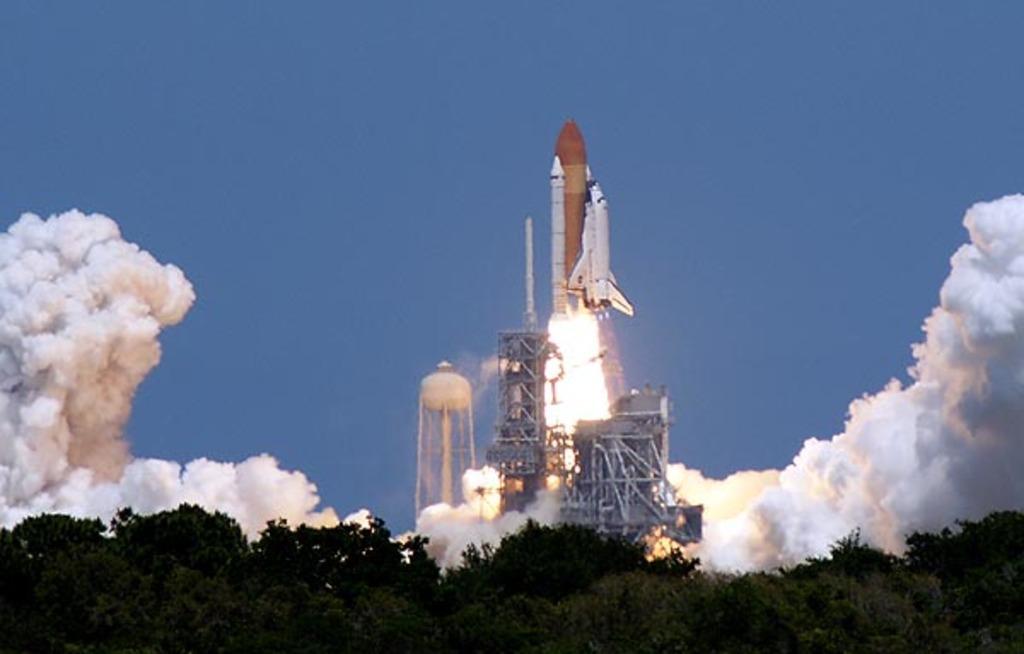In one or two sentences, can you explain what this image depicts? In this image in the center there is one rocket and some towers, and some dog is coming out. At the bottom there are trees, at the top of the image there is sky. 